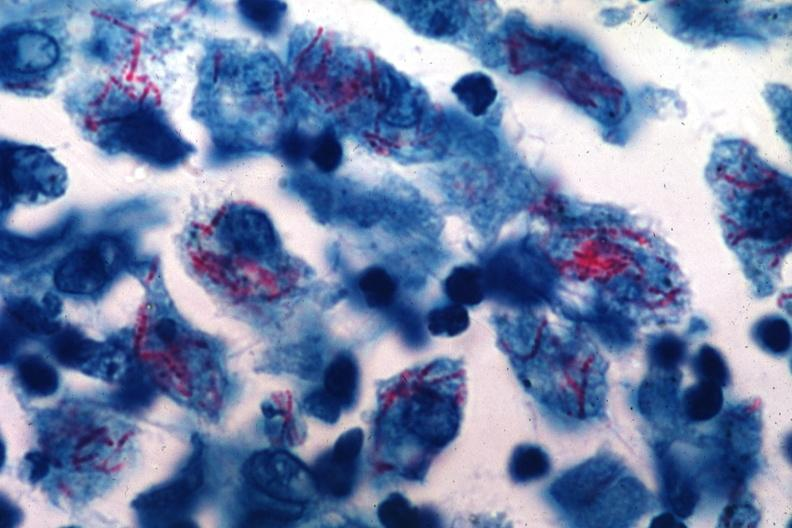how was this an early case of mycobacterium intracellulare infection too organisms for old time tb?
Answer the question using a single word or phrase. Many 